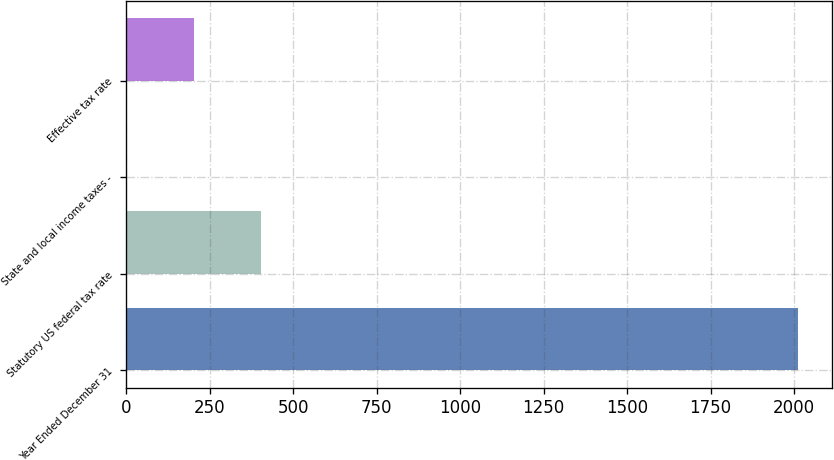<chart> <loc_0><loc_0><loc_500><loc_500><bar_chart><fcel>Year Ended December 31<fcel>Statutory US federal tax rate<fcel>State and local income taxes -<fcel>Effective tax rate<nl><fcel>2012<fcel>403.28<fcel>1.1<fcel>202.19<nl></chart> 